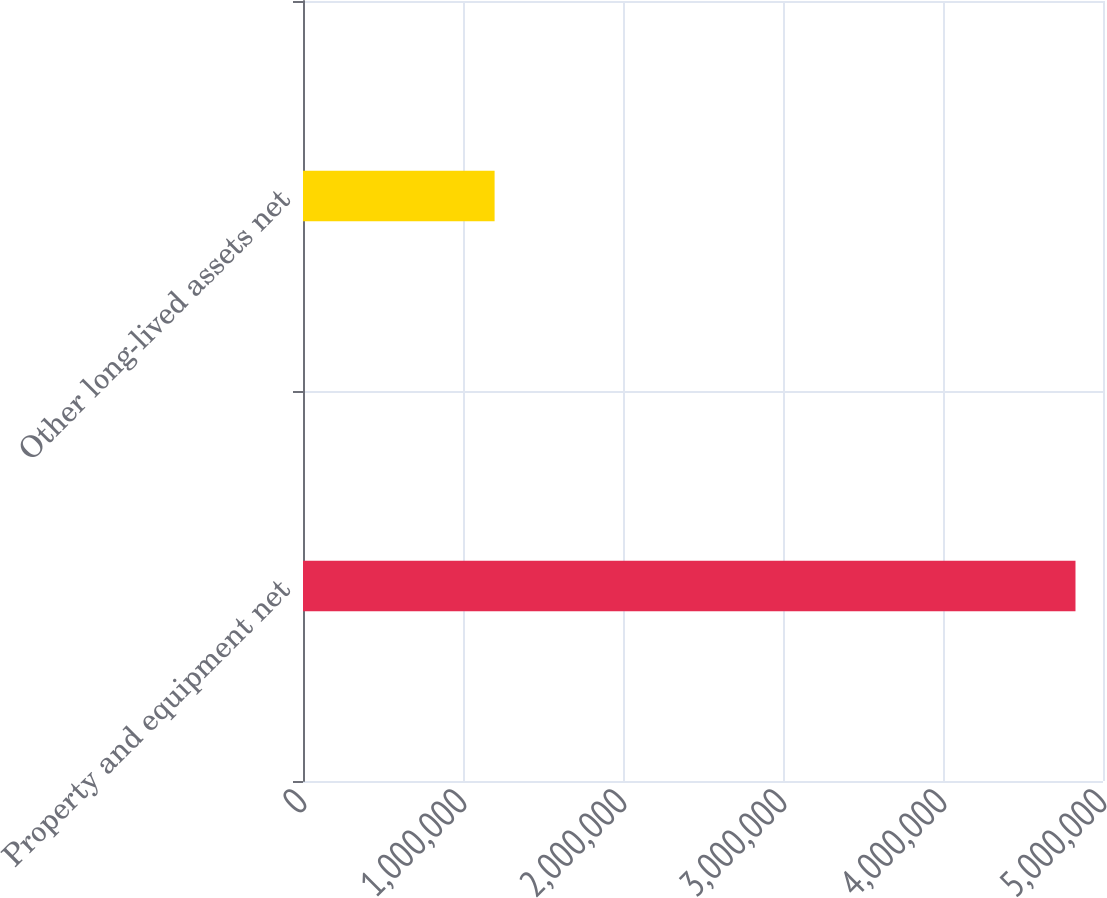<chart> <loc_0><loc_0><loc_500><loc_500><bar_chart><fcel>Property and equipment net<fcel>Other long-lived assets net<nl><fcel>4.82803e+06<fcel>1.19749e+06<nl></chart> 